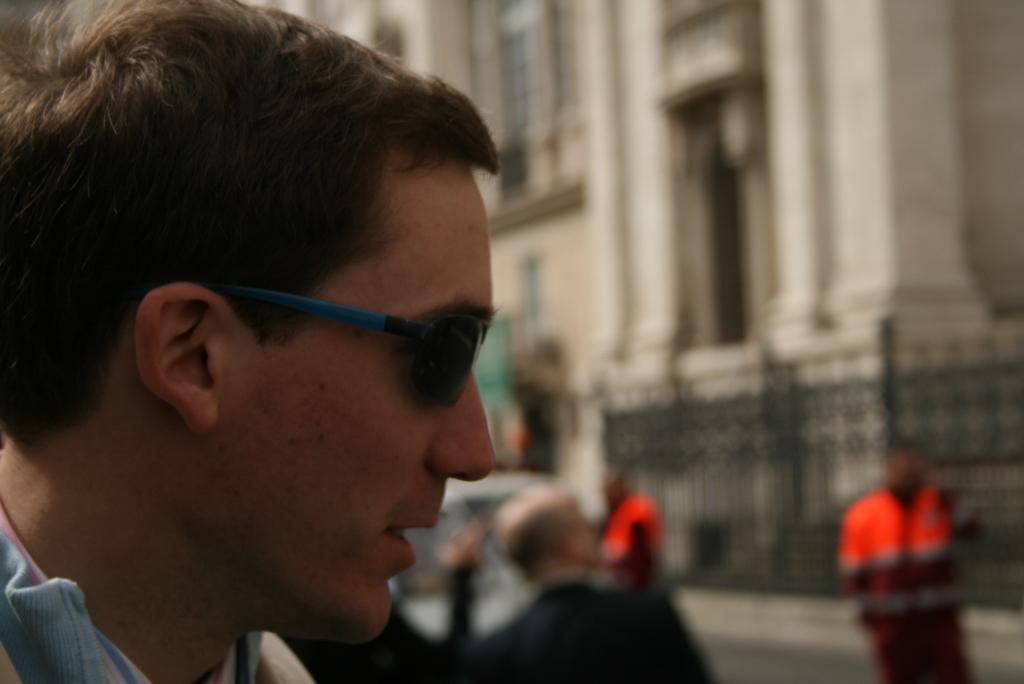What is the main subject of the image? There is a man in the image. What is the man wearing on his face? The man is wearing goggles. Can you describe the background of the image? The background of the image is blurred. How many people are visible in the image? There are people visible in the image. What type of vehicle can be seen in the image? There is a vehicle in the image. What kind of structure is present in the image? There is a building in the image. What type of wing can be seen on the tomatoes in the image? There are no tomatoes or wings present in the image. What territory is being claimed by the people in the image? There is no indication of territory being claimed in the image. 